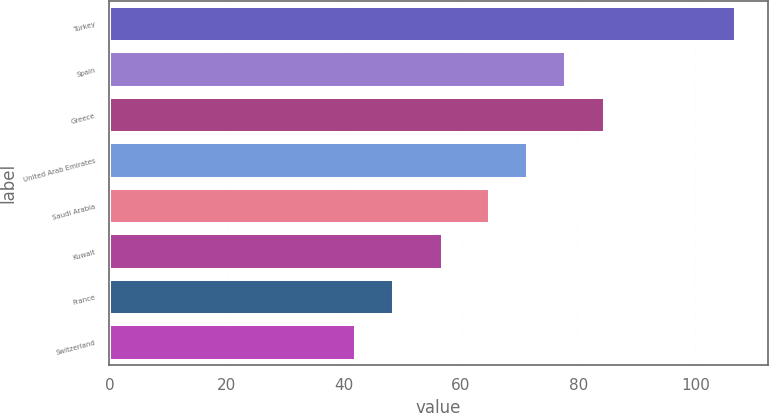Convert chart to OTSL. <chart><loc_0><loc_0><loc_500><loc_500><bar_chart><fcel>Turkey<fcel>Spain<fcel>Greece<fcel>United Arab Emirates<fcel>Saudi Arabia<fcel>Kuwait<fcel>France<fcel>Switzerland<nl><fcel>107<fcel>78<fcel>84.5<fcel>71.5<fcel>65<fcel>57<fcel>48.5<fcel>42<nl></chart> 